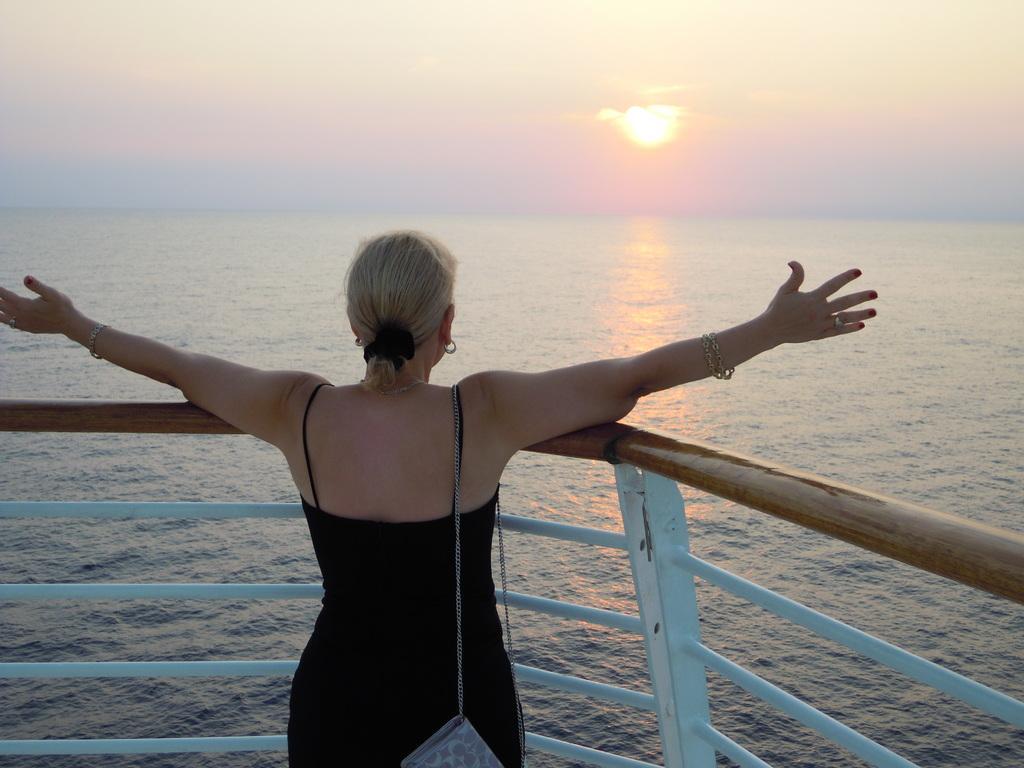How would you summarize this image in a sentence or two? In this image there is a woman standing, in front of her there is a and a river. In the background there is the sky. 